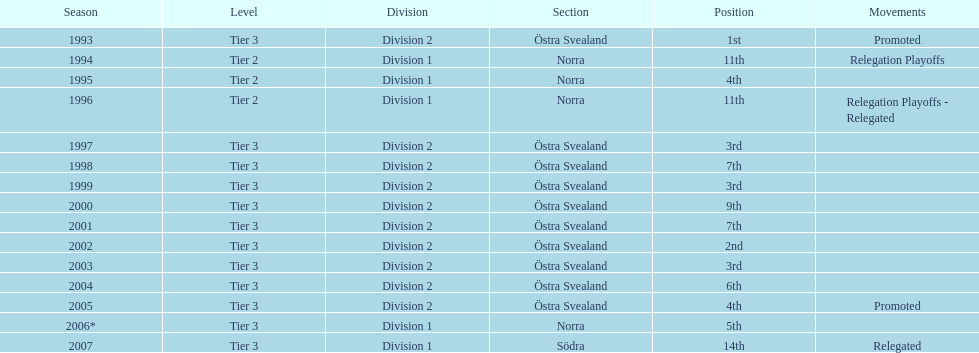In 2000 they finished 9th in their division, did they perform better or worse the next season? Better. 